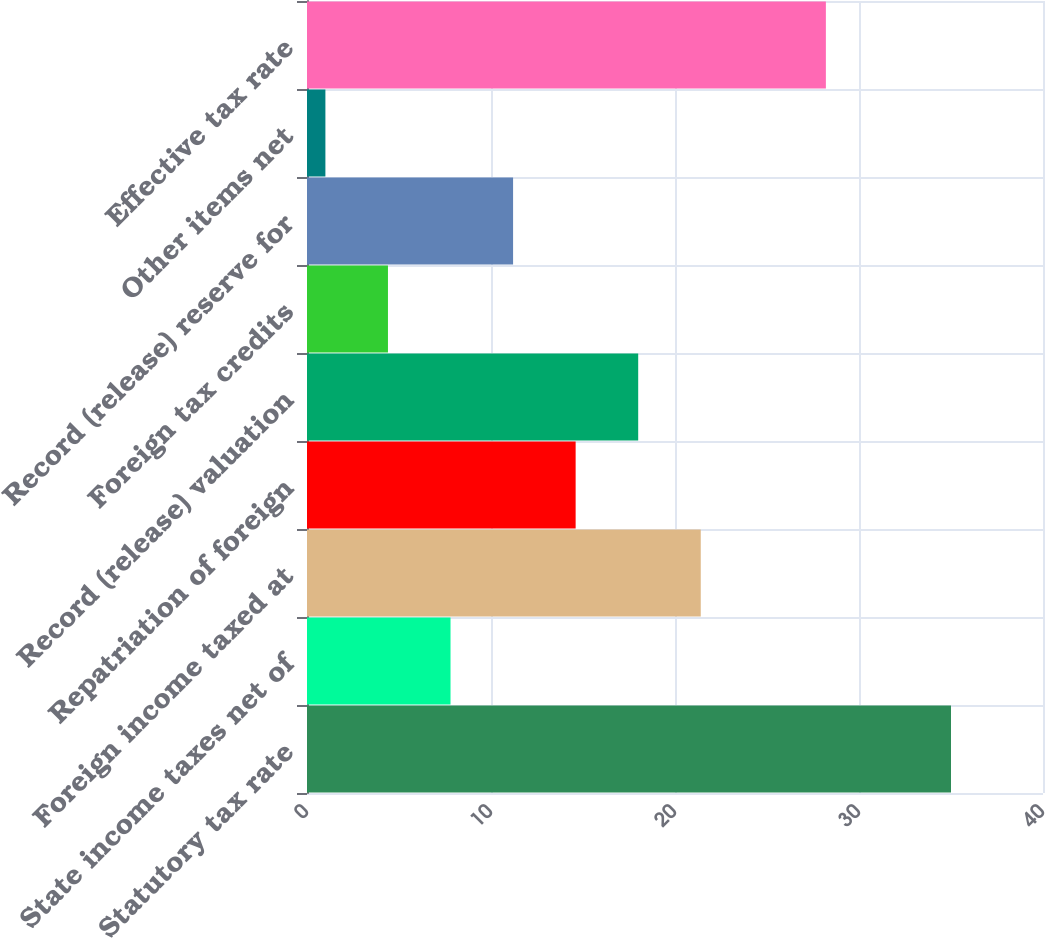Convert chart to OTSL. <chart><loc_0><loc_0><loc_500><loc_500><bar_chart><fcel>Statutory tax rate<fcel>State income taxes net of<fcel>Foreign income taxed at<fcel>Repatriation of foreign<fcel>Record (release) valuation<fcel>Foreign tax credits<fcel>Record (release) reserve for<fcel>Other items net<fcel>Effective tax rate<nl><fcel>35<fcel>7.8<fcel>21.4<fcel>14.6<fcel>18<fcel>4.4<fcel>11.2<fcel>1<fcel>28.2<nl></chart> 